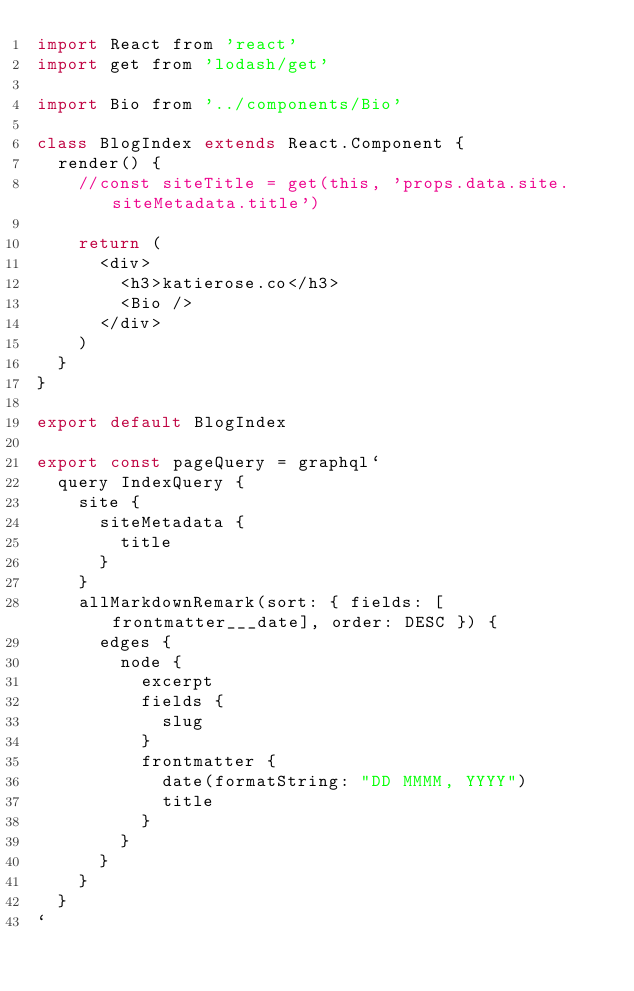<code> <loc_0><loc_0><loc_500><loc_500><_JavaScript_>import React from 'react'
import get from 'lodash/get'

import Bio from '../components/Bio'

class BlogIndex extends React.Component {
  render() {
    //const siteTitle = get(this, 'props.data.site.siteMetadata.title')

    return (
      <div>
        <h3>katierose.co</h3>
        <Bio />
      </div>
    )
  }
}

export default BlogIndex

export const pageQuery = graphql`
  query IndexQuery {
    site {
      siteMetadata {
        title
      }
    }
    allMarkdownRemark(sort: { fields: [frontmatter___date], order: DESC }) {
      edges {
        node {
          excerpt
          fields {
            slug
          }
          frontmatter {
            date(formatString: "DD MMMM, YYYY")
            title
          }
        }
      }
    }
  }
`
</code> 